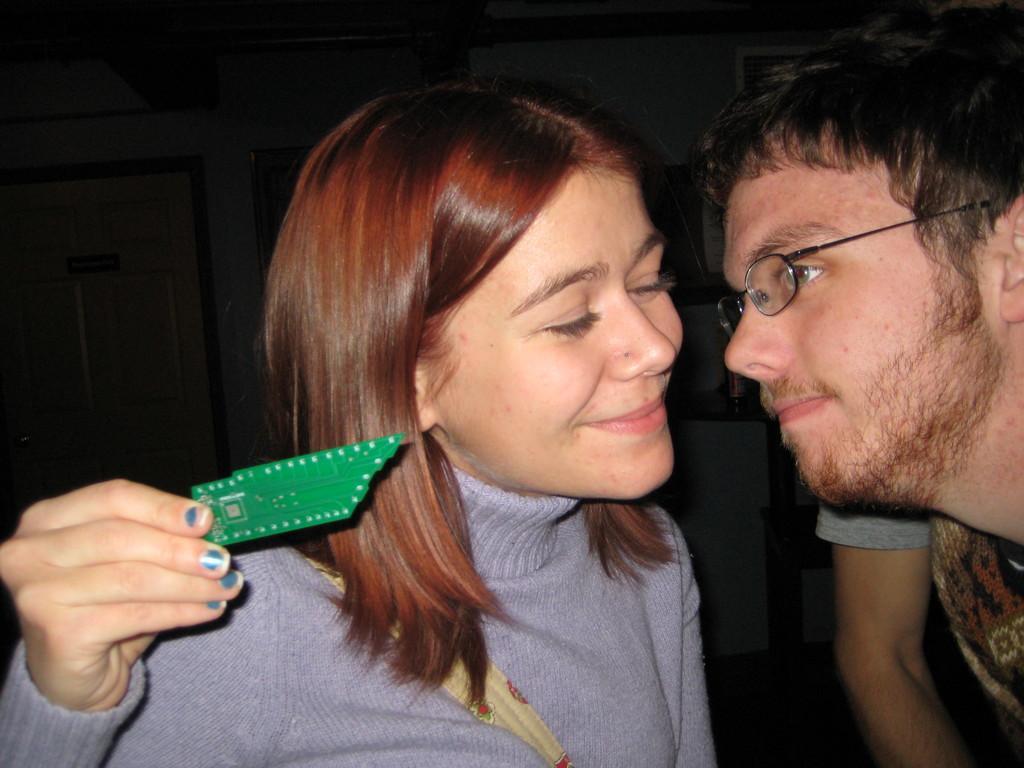Can you describe this image briefly? In this image in the center there is one man and one woman and a woman is holding some object in her hand. In the background there is a wall, doors and some other objects. 